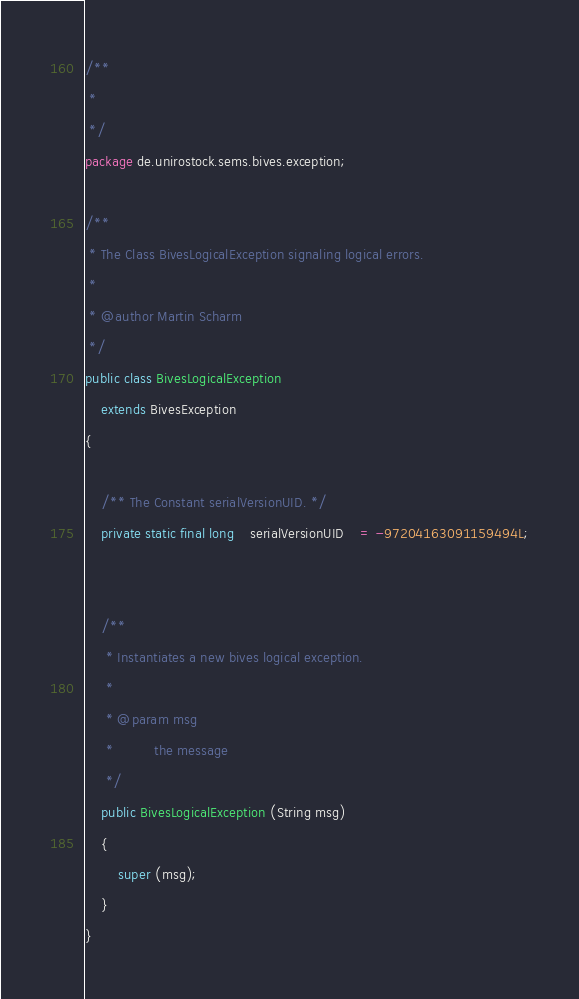Convert code to text. <code><loc_0><loc_0><loc_500><loc_500><_Java_>/**
 * 
 */
package de.unirostock.sems.bives.exception;

/**
 * The Class BivesLogicalException signaling logical errors.
 * 
 * @author Martin Scharm
 */
public class BivesLogicalException
	extends BivesException
{
	
	/** The Constant serialVersionUID. */
	private static final long	serialVersionUID	= -97204163091159494L;
	
	
	/**
	 * Instantiates a new bives logical exception.
	 * 
	 * @param msg
	 *          the message
	 */
	public BivesLogicalException (String msg)
	{
		super (msg);
	}
}
</code> 